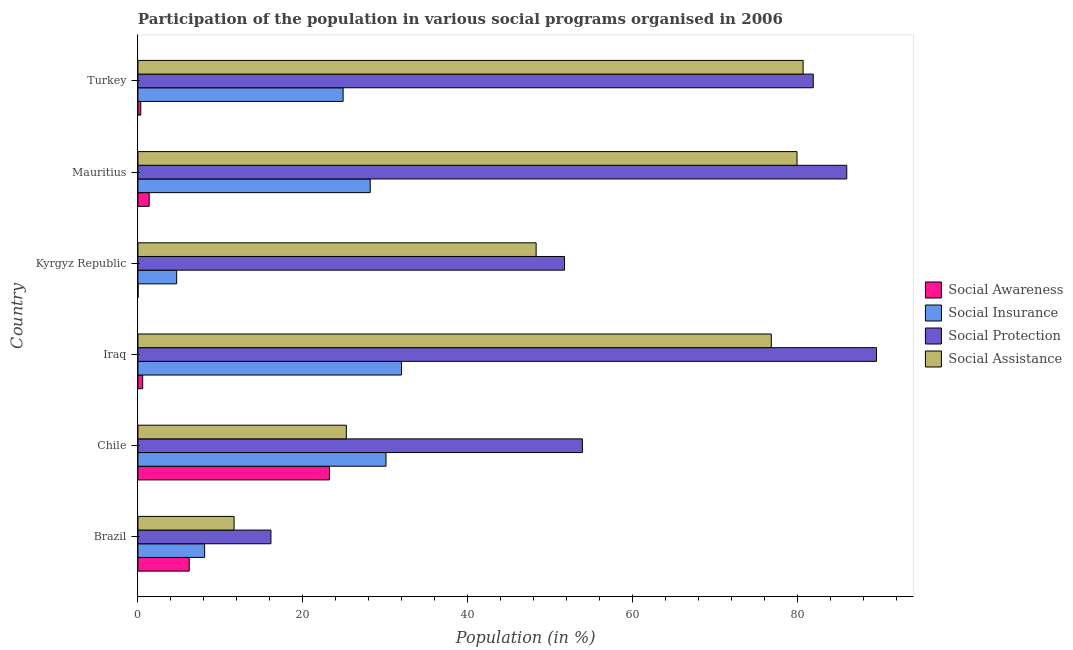How many different coloured bars are there?
Offer a very short reply. 4. Are the number of bars on each tick of the Y-axis equal?
Your response must be concise. Yes. How many bars are there on the 6th tick from the top?
Your response must be concise. 4. What is the label of the 4th group of bars from the top?
Give a very brief answer. Iraq. In how many cases, is the number of bars for a given country not equal to the number of legend labels?
Make the answer very short. 0. What is the participation of population in social awareness programs in Iraq?
Your response must be concise. 0.57. Across all countries, what is the maximum participation of population in social awareness programs?
Provide a succinct answer. 23.24. Across all countries, what is the minimum participation of population in social awareness programs?
Make the answer very short. 0.02. In which country was the participation of population in social protection programs maximum?
Your answer should be very brief. Iraq. What is the total participation of population in social insurance programs in the graph?
Offer a very short reply. 127.95. What is the difference between the participation of population in social insurance programs in Brazil and that in Turkey?
Ensure brevity in your answer.  -16.8. What is the difference between the participation of population in social assistance programs in Brazil and the participation of population in social protection programs in Turkey?
Provide a succinct answer. -70.28. What is the average participation of population in social assistance programs per country?
Keep it short and to the point. 53.8. What is the difference between the participation of population in social insurance programs and participation of population in social awareness programs in Brazil?
Offer a very short reply. 1.87. What is the ratio of the participation of population in social protection programs in Chile to that in Iraq?
Provide a succinct answer. 0.6. Is the difference between the participation of population in social insurance programs in Chile and Kyrgyz Republic greater than the difference between the participation of population in social assistance programs in Chile and Kyrgyz Republic?
Provide a short and direct response. Yes. What is the difference between the highest and the second highest participation of population in social awareness programs?
Give a very brief answer. 17.02. What is the difference between the highest and the lowest participation of population in social insurance programs?
Provide a succinct answer. 27.28. Is the sum of the participation of population in social insurance programs in Brazil and Turkey greater than the maximum participation of population in social assistance programs across all countries?
Your answer should be very brief. No. What does the 2nd bar from the top in Turkey represents?
Provide a short and direct response. Social Protection. What does the 3rd bar from the bottom in Iraq represents?
Provide a short and direct response. Social Protection. Is it the case that in every country, the sum of the participation of population in social awareness programs and participation of population in social insurance programs is greater than the participation of population in social protection programs?
Offer a terse response. No. How many countries are there in the graph?
Ensure brevity in your answer.  6. What is the difference between two consecutive major ticks on the X-axis?
Make the answer very short. 20. Are the values on the major ticks of X-axis written in scientific E-notation?
Ensure brevity in your answer.  No. Does the graph contain any zero values?
Give a very brief answer. No. Does the graph contain grids?
Offer a terse response. No. Where does the legend appear in the graph?
Your answer should be compact. Center right. What is the title of the graph?
Ensure brevity in your answer.  Participation of the population in various social programs organised in 2006. What is the label or title of the Y-axis?
Offer a terse response. Country. What is the Population (in %) in Social Awareness in Brazil?
Keep it short and to the point. 6.22. What is the Population (in %) of Social Insurance in Brazil?
Your answer should be compact. 8.09. What is the Population (in %) in Social Protection in Brazil?
Offer a terse response. 16.14. What is the Population (in %) of Social Assistance in Brazil?
Keep it short and to the point. 11.67. What is the Population (in %) in Social Awareness in Chile?
Offer a very short reply. 23.24. What is the Population (in %) in Social Insurance in Chile?
Your answer should be very brief. 30.1. What is the Population (in %) in Social Protection in Chile?
Provide a short and direct response. 53.93. What is the Population (in %) in Social Assistance in Chile?
Provide a succinct answer. 25.29. What is the Population (in %) of Social Awareness in Iraq?
Your answer should be very brief. 0.57. What is the Population (in %) in Social Insurance in Iraq?
Keep it short and to the point. 31.98. What is the Population (in %) in Social Protection in Iraq?
Give a very brief answer. 89.62. What is the Population (in %) of Social Assistance in Iraq?
Make the answer very short. 76.86. What is the Population (in %) of Social Awareness in Kyrgyz Republic?
Provide a succinct answer. 0.02. What is the Population (in %) of Social Insurance in Kyrgyz Republic?
Make the answer very short. 4.7. What is the Population (in %) of Social Protection in Kyrgyz Republic?
Offer a very short reply. 51.76. What is the Population (in %) of Social Assistance in Kyrgyz Republic?
Provide a short and direct response. 48.32. What is the Population (in %) of Social Awareness in Mauritius?
Offer a very short reply. 1.36. What is the Population (in %) in Social Insurance in Mauritius?
Your response must be concise. 28.19. What is the Population (in %) of Social Protection in Mauritius?
Provide a short and direct response. 86.01. What is the Population (in %) in Social Assistance in Mauritius?
Your response must be concise. 79.97. What is the Population (in %) of Social Awareness in Turkey?
Your response must be concise. 0.34. What is the Population (in %) of Social Insurance in Turkey?
Provide a short and direct response. 24.9. What is the Population (in %) in Social Protection in Turkey?
Make the answer very short. 81.95. What is the Population (in %) in Social Assistance in Turkey?
Your answer should be compact. 80.72. Across all countries, what is the maximum Population (in %) of Social Awareness?
Provide a short and direct response. 23.24. Across all countries, what is the maximum Population (in %) of Social Insurance?
Provide a short and direct response. 31.98. Across all countries, what is the maximum Population (in %) in Social Protection?
Your answer should be very brief. 89.62. Across all countries, what is the maximum Population (in %) of Social Assistance?
Your answer should be compact. 80.72. Across all countries, what is the minimum Population (in %) of Social Awareness?
Give a very brief answer. 0.02. Across all countries, what is the minimum Population (in %) of Social Insurance?
Provide a short and direct response. 4.7. Across all countries, what is the minimum Population (in %) of Social Protection?
Your response must be concise. 16.14. Across all countries, what is the minimum Population (in %) in Social Assistance?
Your answer should be very brief. 11.67. What is the total Population (in %) in Social Awareness in the graph?
Give a very brief answer. 31.75. What is the total Population (in %) of Social Insurance in the graph?
Offer a terse response. 127.95. What is the total Population (in %) in Social Protection in the graph?
Your answer should be very brief. 379.42. What is the total Population (in %) in Social Assistance in the graph?
Offer a very short reply. 322.82. What is the difference between the Population (in %) of Social Awareness in Brazil and that in Chile?
Offer a terse response. -17.02. What is the difference between the Population (in %) in Social Insurance in Brazil and that in Chile?
Provide a succinct answer. -22.01. What is the difference between the Population (in %) of Social Protection in Brazil and that in Chile?
Keep it short and to the point. -37.8. What is the difference between the Population (in %) in Social Assistance in Brazil and that in Chile?
Provide a succinct answer. -13.62. What is the difference between the Population (in %) of Social Awareness in Brazil and that in Iraq?
Give a very brief answer. 5.65. What is the difference between the Population (in %) in Social Insurance in Brazil and that in Iraq?
Ensure brevity in your answer.  -23.89. What is the difference between the Population (in %) in Social Protection in Brazil and that in Iraq?
Make the answer very short. -73.48. What is the difference between the Population (in %) of Social Assistance in Brazil and that in Iraq?
Give a very brief answer. -65.19. What is the difference between the Population (in %) in Social Awareness in Brazil and that in Kyrgyz Republic?
Keep it short and to the point. 6.21. What is the difference between the Population (in %) of Social Insurance in Brazil and that in Kyrgyz Republic?
Keep it short and to the point. 3.39. What is the difference between the Population (in %) in Social Protection in Brazil and that in Kyrgyz Republic?
Your response must be concise. -35.63. What is the difference between the Population (in %) of Social Assistance in Brazil and that in Kyrgyz Republic?
Your answer should be compact. -36.65. What is the difference between the Population (in %) of Social Awareness in Brazil and that in Mauritius?
Offer a terse response. 4.86. What is the difference between the Population (in %) in Social Insurance in Brazil and that in Mauritius?
Your answer should be very brief. -20.09. What is the difference between the Population (in %) of Social Protection in Brazil and that in Mauritius?
Your answer should be very brief. -69.88. What is the difference between the Population (in %) in Social Assistance in Brazil and that in Mauritius?
Make the answer very short. -68.31. What is the difference between the Population (in %) in Social Awareness in Brazil and that in Turkey?
Offer a terse response. 5.88. What is the difference between the Population (in %) of Social Insurance in Brazil and that in Turkey?
Offer a very short reply. -16.8. What is the difference between the Population (in %) in Social Protection in Brazil and that in Turkey?
Offer a terse response. -65.81. What is the difference between the Population (in %) in Social Assistance in Brazil and that in Turkey?
Ensure brevity in your answer.  -69.05. What is the difference between the Population (in %) in Social Awareness in Chile and that in Iraq?
Your answer should be very brief. 22.67. What is the difference between the Population (in %) of Social Insurance in Chile and that in Iraq?
Make the answer very short. -1.88. What is the difference between the Population (in %) in Social Protection in Chile and that in Iraq?
Offer a terse response. -35.69. What is the difference between the Population (in %) in Social Assistance in Chile and that in Iraq?
Your response must be concise. -51.57. What is the difference between the Population (in %) of Social Awareness in Chile and that in Kyrgyz Republic?
Offer a terse response. 23.22. What is the difference between the Population (in %) of Social Insurance in Chile and that in Kyrgyz Republic?
Your answer should be compact. 25.4. What is the difference between the Population (in %) of Social Protection in Chile and that in Kyrgyz Republic?
Offer a terse response. 2.17. What is the difference between the Population (in %) of Social Assistance in Chile and that in Kyrgyz Republic?
Provide a succinct answer. -23.03. What is the difference between the Population (in %) in Social Awareness in Chile and that in Mauritius?
Offer a very short reply. 21.87. What is the difference between the Population (in %) of Social Insurance in Chile and that in Mauritius?
Keep it short and to the point. 1.92. What is the difference between the Population (in %) of Social Protection in Chile and that in Mauritius?
Offer a terse response. -32.08. What is the difference between the Population (in %) in Social Assistance in Chile and that in Mauritius?
Offer a very short reply. -54.69. What is the difference between the Population (in %) of Social Awareness in Chile and that in Turkey?
Provide a succinct answer. 22.9. What is the difference between the Population (in %) of Social Insurance in Chile and that in Turkey?
Offer a very short reply. 5.21. What is the difference between the Population (in %) in Social Protection in Chile and that in Turkey?
Your response must be concise. -28.02. What is the difference between the Population (in %) in Social Assistance in Chile and that in Turkey?
Keep it short and to the point. -55.43. What is the difference between the Population (in %) of Social Awareness in Iraq and that in Kyrgyz Republic?
Make the answer very short. 0.56. What is the difference between the Population (in %) of Social Insurance in Iraq and that in Kyrgyz Republic?
Ensure brevity in your answer.  27.28. What is the difference between the Population (in %) in Social Protection in Iraq and that in Kyrgyz Republic?
Provide a short and direct response. 37.86. What is the difference between the Population (in %) of Social Assistance in Iraq and that in Kyrgyz Republic?
Your answer should be compact. 28.54. What is the difference between the Population (in %) in Social Awareness in Iraq and that in Mauritius?
Your answer should be compact. -0.79. What is the difference between the Population (in %) of Social Insurance in Iraq and that in Mauritius?
Give a very brief answer. 3.79. What is the difference between the Population (in %) of Social Protection in Iraq and that in Mauritius?
Offer a very short reply. 3.61. What is the difference between the Population (in %) in Social Assistance in Iraq and that in Mauritius?
Offer a very short reply. -3.12. What is the difference between the Population (in %) of Social Awareness in Iraq and that in Turkey?
Keep it short and to the point. 0.23. What is the difference between the Population (in %) of Social Insurance in Iraq and that in Turkey?
Provide a short and direct response. 7.08. What is the difference between the Population (in %) of Social Protection in Iraq and that in Turkey?
Give a very brief answer. 7.67. What is the difference between the Population (in %) in Social Assistance in Iraq and that in Turkey?
Provide a short and direct response. -3.86. What is the difference between the Population (in %) in Social Awareness in Kyrgyz Republic and that in Mauritius?
Provide a succinct answer. -1.35. What is the difference between the Population (in %) in Social Insurance in Kyrgyz Republic and that in Mauritius?
Provide a succinct answer. -23.49. What is the difference between the Population (in %) of Social Protection in Kyrgyz Republic and that in Mauritius?
Your response must be concise. -34.25. What is the difference between the Population (in %) in Social Assistance in Kyrgyz Republic and that in Mauritius?
Offer a terse response. -31.66. What is the difference between the Population (in %) of Social Awareness in Kyrgyz Republic and that in Turkey?
Keep it short and to the point. -0.33. What is the difference between the Population (in %) of Social Insurance in Kyrgyz Republic and that in Turkey?
Your response must be concise. -20.2. What is the difference between the Population (in %) in Social Protection in Kyrgyz Republic and that in Turkey?
Offer a very short reply. -30.19. What is the difference between the Population (in %) in Social Assistance in Kyrgyz Republic and that in Turkey?
Provide a succinct answer. -32.4. What is the difference between the Population (in %) in Social Awareness in Mauritius and that in Turkey?
Give a very brief answer. 1.02. What is the difference between the Population (in %) in Social Insurance in Mauritius and that in Turkey?
Offer a very short reply. 3.29. What is the difference between the Population (in %) in Social Protection in Mauritius and that in Turkey?
Your response must be concise. 4.07. What is the difference between the Population (in %) in Social Assistance in Mauritius and that in Turkey?
Your answer should be very brief. -0.74. What is the difference between the Population (in %) of Social Awareness in Brazil and the Population (in %) of Social Insurance in Chile?
Your answer should be very brief. -23.88. What is the difference between the Population (in %) in Social Awareness in Brazil and the Population (in %) in Social Protection in Chile?
Your answer should be very brief. -47.71. What is the difference between the Population (in %) in Social Awareness in Brazil and the Population (in %) in Social Assistance in Chile?
Make the answer very short. -19.07. What is the difference between the Population (in %) of Social Insurance in Brazil and the Population (in %) of Social Protection in Chile?
Your answer should be compact. -45.84. What is the difference between the Population (in %) in Social Insurance in Brazil and the Population (in %) in Social Assistance in Chile?
Ensure brevity in your answer.  -17.2. What is the difference between the Population (in %) in Social Protection in Brazil and the Population (in %) in Social Assistance in Chile?
Make the answer very short. -9.15. What is the difference between the Population (in %) of Social Awareness in Brazil and the Population (in %) of Social Insurance in Iraq?
Offer a terse response. -25.76. What is the difference between the Population (in %) in Social Awareness in Brazil and the Population (in %) in Social Protection in Iraq?
Give a very brief answer. -83.4. What is the difference between the Population (in %) in Social Awareness in Brazil and the Population (in %) in Social Assistance in Iraq?
Offer a terse response. -70.64. What is the difference between the Population (in %) of Social Insurance in Brazil and the Population (in %) of Social Protection in Iraq?
Provide a short and direct response. -81.53. What is the difference between the Population (in %) in Social Insurance in Brazil and the Population (in %) in Social Assistance in Iraq?
Offer a terse response. -68.76. What is the difference between the Population (in %) of Social Protection in Brazil and the Population (in %) of Social Assistance in Iraq?
Your response must be concise. -60.72. What is the difference between the Population (in %) of Social Awareness in Brazil and the Population (in %) of Social Insurance in Kyrgyz Republic?
Offer a very short reply. 1.52. What is the difference between the Population (in %) in Social Awareness in Brazil and the Population (in %) in Social Protection in Kyrgyz Republic?
Your answer should be compact. -45.54. What is the difference between the Population (in %) in Social Awareness in Brazil and the Population (in %) in Social Assistance in Kyrgyz Republic?
Provide a succinct answer. -42.1. What is the difference between the Population (in %) of Social Insurance in Brazil and the Population (in %) of Social Protection in Kyrgyz Republic?
Keep it short and to the point. -43.67. What is the difference between the Population (in %) in Social Insurance in Brazil and the Population (in %) in Social Assistance in Kyrgyz Republic?
Make the answer very short. -40.23. What is the difference between the Population (in %) in Social Protection in Brazil and the Population (in %) in Social Assistance in Kyrgyz Republic?
Your answer should be very brief. -32.18. What is the difference between the Population (in %) of Social Awareness in Brazil and the Population (in %) of Social Insurance in Mauritius?
Provide a succinct answer. -21.96. What is the difference between the Population (in %) in Social Awareness in Brazil and the Population (in %) in Social Protection in Mauritius?
Make the answer very short. -79.79. What is the difference between the Population (in %) of Social Awareness in Brazil and the Population (in %) of Social Assistance in Mauritius?
Offer a terse response. -73.75. What is the difference between the Population (in %) of Social Insurance in Brazil and the Population (in %) of Social Protection in Mauritius?
Your answer should be very brief. -77.92. What is the difference between the Population (in %) in Social Insurance in Brazil and the Population (in %) in Social Assistance in Mauritius?
Ensure brevity in your answer.  -71.88. What is the difference between the Population (in %) in Social Protection in Brazil and the Population (in %) in Social Assistance in Mauritius?
Ensure brevity in your answer.  -63.84. What is the difference between the Population (in %) of Social Awareness in Brazil and the Population (in %) of Social Insurance in Turkey?
Your response must be concise. -18.67. What is the difference between the Population (in %) of Social Awareness in Brazil and the Population (in %) of Social Protection in Turkey?
Provide a short and direct response. -75.73. What is the difference between the Population (in %) in Social Awareness in Brazil and the Population (in %) in Social Assistance in Turkey?
Offer a terse response. -74.5. What is the difference between the Population (in %) in Social Insurance in Brazil and the Population (in %) in Social Protection in Turkey?
Your answer should be very brief. -73.86. What is the difference between the Population (in %) in Social Insurance in Brazil and the Population (in %) in Social Assistance in Turkey?
Give a very brief answer. -72.63. What is the difference between the Population (in %) of Social Protection in Brazil and the Population (in %) of Social Assistance in Turkey?
Provide a short and direct response. -64.58. What is the difference between the Population (in %) in Social Awareness in Chile and the Population (in %) in Social Insurance in Iraq?
Give a very brief answer. -8.74. What is the difference between the Population (in %) of Social Awareness in Chile and the Population (in %) of Social Protection in Iraq?
Ensure brevity in your answer.  -66.38. What is the difference between the Population (in %) of Social Awareness in Chile and the Population (in %) of Social Assistance in Iraq?
Make the answer very short. -53.62. What is the difference between the Population (in %) of Social Insurance in Chile and the Population (in %) of Social Protection in Iraq?
Your answer should be compact. -59.52. What is the difference between the Population (in %) in Social Insurance in Chile and the Population (in %) in Social Assistance in Iraq?
Your answer should be very brief. -46.76. What is the difference between the Population (in %) of Social Protection in Chile and the Population (in %) of Social Assistance in Iraq?
Make the answer very short. -22.92. What is the difference between the Population (in %) of Social Awareness in Chile and the Population (in %) of Social Insurance in Kyrgyz Republic?
Your answer should be compact. 18.54. What is the difference between the Population (in %) of Social Awareness in Chile and the Population (in %) of Social Protection in Kyrgyz Republic?
Your response must be concise. -28.53. What is the difference between the Population (in %) of Social Awareness in Chile and the Population (in %) of Social Assistance in Kyrgyz Republic?
Give a very brief answer. -25.08. What is the difference between the Population (in %) in Social Insurance in Chile and the Population (in %) in Social Protection in Kyrgyz Republic?
Your response must be concise. -21.66. What is the difference between the Population (in %) in Social Insurance in Chile and the Population (in %) in Social Assistance in Kyrgyz Republic?
Make the answer very short. -18.22. What is the difference between the Population (in %) of Social Protection in Chile and the Population (in %) of Social Assistance in Kyrgyz Republic?
Provide a short and direct response. 5.62. What is the difference between the Population (in %) of Social Awareness in Chile and the Population (in %) of Social Insurance in Mauritius?
Provide a succinct answer. -4.95. What is the difference between the Population (in %) of Social Awareness in Chile and the Population (in %) of Social Protection in Mauritius?
Offer a terse response. -62.78. What is the difference between the Population (in %) in Social Awareness in Chile and the Population (in %) in Social Assistance in Mauritius?
Provide a short and direct response. -56.74. What is the difference between the Population (in %) in Social Insurance in Chile and the Population (in %) in Social Protection in Mauritius?
Keep it short and to the point. -55.91. What is the difference between the Population (in %) of Social Insurance in Chile and the Population (in %) of Social Assistance in Mauritius?
Offer a very short reply. -49.87. What is the difference between the Population (in %) of Social Protection in Chile and the Population (in %) of Social Assistance in Mauritius?
Provide a short and direct response. -26.04. What is the difference between the Population (in %) of Social Awareness in Chile and the Population (in %) of Social Insurance in Turkey?
Make the answer very short. -1.66. What is the difference between the Population (in %) in Social Awareness in Chile and the Population (in %) in Social Protection in Turkey?
Ensure brevity in your answer.  -58.71. What is the difference between the Population (in %) in Social Awareness in Chile and the Population (in %) in Social Assistance in Turkey?
Provide a succinct answer. -57.48. What is the difference between the Population (in %) of Social Insurance in Chile and the Population (in %) of Social Protection in Turkey?
Your answer should be compact. -51.85. What is the difference between the Population (in %) in Social Insurance in Chile and the Population (in %) in Social Assistance in Turkey?
Give a very brief answer. -50.62. What is the difference between the Population (in %) of Social Protection in Chile and the Population (in %) of Social Assistance in Turkey?
Your answer should be very brief. -26.79. What is the difference between the Population (in %) in Social Awareness in Iraq and the Population (in %) in Social Insurance in Kyrgyz Republic?
Provide a short and direct response. -4.13. What is the difference between the Population (in %) in Social Awareness in Iraq and the Population (in %) in Social Protection in Kyrgyz Republic?
Give a very brief answer. -51.19. What is the difference between the Population (in %) in Social Awareness in Iraq and the Population (in %) in Social Assistance in Kyrgyz Republic?
Give a very brief answer. -47.75. What is the difference between the Population (in %) of Social Insurance in Iraq and the Population (in %) of Social Protection in Kyrgyz Republic?
Give a very brief answer. -19.78. What is the difference between the Population (in %) of Social Insurance in Iraq and the Population (in %) of Social Assistance in Kyrgyz Republic?
Provide a succinct answer. -16.34. What is the difference between the Population (in %) of Social Protection in Iraq and the Population (in %) of Social Assistance in Kyrgyz Republic?
Offer a terse response. 41.3. What is the difference between the Population (in %) in Social Awareness in Iraq and the Population (in %) in Social Insurance in Mauritius?
Make the answer very short. -27.61. What is the difference between the Population (in %) in Social Awareness in Iraq and the Population (in %) in Social Protection in Mauritius?
Offer a very short reply. -85.44. What is the difference between the Population (in %) in Social Awareness in Iraq and the Population (in %) in Social Assistance in Mauritius?
Provide a succinct answer. -79.4. What is the difference between the Population (in %) in Social Insurance in Iraq and the Population (in %) in Social Protection in Mauritius?
Offer a terse response. -54.04. What is the difference between the Population (in %) in Social Insurance in Iraq and the Population (in %) in Social Assistance in Mauritius?
Make the answer very short. -48. What is the difference between the Population (in %) in Social Protection in Iraq and the Population (in %) in Social Assistance in Mauritius?
Ensure brevity in your answer.  9.65. What is the difference between the Population (in %) of Social Awareness in Iraq and the Population (in %) of Social Insurance in Turkey?
Offer a very short reply. -24.32. What is the difference between the Population (in %) of Social Awareness in Iraq and the Population (in %) of Social Protection in Turkey?
Keep it short and to the point. -81.38. What is the difference between the Population (in %) in Social Awareness in Iraq and the Population (in %) in Social Assistance in Turkey?
Your answer should be very brief. -80.15. What is the difference between the Population (in %) of Social Insurance in Iraq and the Population (in %) of Social Protection in Turkey?
Give a very brief answer. -49.97. What is the difference between the Population (in %) in Social Insurance in Iraq and the Population (in %) in Social Assistance in Turkey?
Provide a succinct answer. -48.74. What is the difference between the Population (in %) in Social Protection in Iraq and the Population (in %) in Social Assistance in Turkey?
Provide a short and direct response. 8.9. What is the difference between the Population (in %) in Social Awareness in Kyrgyz Republic and the Population (in %) in Social Insurance in Mauritius?
Provide a succinct answer. -28.17. What is the difference between the Population (in %) of Social Awareness in Kyrgyz Republic and the Population (in %) of Social Protection in Mauritius?
Provide a succinct answer. -86. What is the difference between the Population (in %) in Social Awareness in Kyrgyz Republic and the Population (in %) in Social Assistance in Mauritius?
Offer a terse response. -79.96. What is the difference between the Population (in %) of Social Insurance in Kyrgyz Republic and the Population (in %) of Social Protection in Mauritius?
Provide a succinct answer. -81.32. What is the difference between the Population (in %) of Social Insurance in Kyrgyz Republic and the Population (in %) of Social Assistance in Mauritius?
Provide a short and direct response. -75.28. What is the difference between the Population (in %) in Social Protection in Kyrgyz Republic and the Population (in %) in Social Assistance in Mauritius?
Your answer should be very brief. -28.21. What is the difference between the Population (in %) of Social Awareness in Kyrgyz Republic and the Population (in %) of Social Insurance in Turkey?
Offer a terse response. -24.88. What is the difference between the Population (in %) of Social Awareness in Kyrgyz Republic and the Population (in %) of Social Protection in Turkey?
Your answer should be very brief. -81.93. What is the difference between the Population (in %) in Social Awareness in Kyrgyz Republic and the Population (in %) in Social Assistance in Turkey?
Offer a very short reply. -80.7. What is the difference between the Population (in %) in Social Insurance in Kyrgyz Republic and the Population (in %) in Social Protection in Turkey?
Offer a very short reply. -77.25. What is the difference between the Population (in %) in Social Insurance in Kyrgyz Republic and the Population (in %) in Social Assistance in Turkey?
Provide a short and direct response. -76.02. What is the difference between the Population (in %) of Social Protection in Kyrgyz Republic and the Population (in %) of Social Assistance in Turkey?
Give a very brief answer. -28.96. What is the difference between the Population (in %) in Social Awareness in Mauritius and the Population (in %) in Social Insurance in Turkey?
Make the answer very short. -23.53. What is the difference between the Population (in %) in Social Awareness in Mauritius and the Population (in %) in Social Protection in Turkey?
Ensure brevity in your answer.  -80.59. What is the difference between the Population (in %) of Social Awareness in Mauritius and the Population (in %) of Social Assistance in Turkey?
Ensure brevity in your answer.  -79.36. What is the difference between the Population (in %) in Social Insurance in Mauritius and the Population (in %) in Social Protection in Turkey?
Your answer should be compact. -53.76. What is the difference between the Population (in %) in Social Insurance in Mauritius and the Population (in %) in Social Assistance in Turkey?
Make the answer very short. -52.53. What is the difference between the Population (in %) of Social Protection in Mauritius and the Population (in %) of Social Assistance in Turkey?
Provide a succinct answer. 5.3. What is the average Population (in %) in Social Awareness per country?
Ensure brevity in your answer.  5.29. What is the average Population (in %) of Social Insurance per country?
Give a very brief answer. 21.33. What is the average Population (in %) in Social Protection per country?
Keep it short and to the point. 63.24. What is the average Population (in %) of Social Assistance per country?
Keep it short and to the point. 53.8. What is the difference between the Population (in %) of Social Awareness and Population (in %) of Social Insurance in Brazil?
Keep it short and to the point. -1.87. What is the difference between the Population (in %) in Social Awareness and Population (in %) in Social Protection in Brazil?
Give a very brief answer. -9.92. What is the difference between the Population (in %) in Social Awareness and Population (in %) in Social Assistance in Brazil?
Ensure brevity in your answer.  -5.44. What is the difference between the Population (in %) of Social Insurance and Population (in %) of Social Protection in Brazil?
Offer a terse response. -8.04. What is the difference between the Population (in %) of Social Insurance and Population (in %) of Social Assistance in Brazil?
Ensure brevity in your answer.  -3.57. What is the difference between the Population (in %) in Social Protection and Population (in %) in Social Assistance in Brazil?
Offer a terse response. 4.47. What is the difference between the Population (in %) of Social Awareness and Population (in %) of Social Insurance in Chile?
Your answer should be compact. -6.86. What is the difference between the Population (in %) in Social Awareness and Population (in %) in Social Protection in Chile?
Make the answer very short. -30.7. What is the difference between the Population (in %) in Social Awareness and Population (in %) in Social Assistance in Chile?
Your response must be concise. -2.05. What is the difference between the Population (in %) of Social Insurance and Population (in %) of Social Protection in Chile?
Offer a terse response. -23.83. What is the difference between the Population (in %) of Social Insurance and Population (in %) of Social Assistance in Chile?
Give a very brief answer. 4.81. What is the difference between the Population (in %) in Social Protection and Population (in %) in Social Assistance in Chile?
Ensure brevity in your answer.  28.64. What is the difference between the Population (in %) in Social Awareness and Population (in %) in Social Insurance in Iraq?
Ensure brevity in your answer.  -31.41. What is the difference between the Population (in %) in Social Awareness and Population (in %) in Social Protection in Iraq?
Your answer should be very brief. -89.05. What is the difference between the Population (in %) of Social Awareness and Population (in %) of Social Assistance in Iraq?
Provide a succinct answer. -76.29. What is the difference between the Population (in %) of Social Insurance and Population (in %) of Social Protection in Iraq?
Your answer should be very brief. -57.64. What is the difference between the Population (in %) in Social Insurance and Population (in %) in Social Assistance in Iraq?
Ensure brevity in your answer.  -44.88. What is the difference between the Population (in %) in Social Protection and Population (in %) in Social Assistance in Iraq?
Make the answer very short. 12.76. What is the difference between the Population (in %) of Social Awareness and Population (in %) of Social Insurance in Kyrgyz Republic?
Provide a short and direct response. -4.68. What is the difference between the Population (in %) in Social Awareness and Population (in %) in Social Protection in Kyrgyz Republic?
Provide a short and direct response. -51.75. What is the difference between the Population (in %) of Social Awareness and Population (in %) of Social Assistance in Kyrgyz Republic?
Keep it short and to the point. -48.3. What is the difference between the Population (in %) of Social Insurance and Population (in %) of Social Protection in Kyrgyz Republic?
Make the answer very short. -47.06. What is the difference between the Population (in %) in Social Insurance and Population (in %) in Social Assistance in Kyrgyz Republic?
Your response must be concise. -43.62. What is the difference between the Population (in %) of Social Protection and Population (in %) of Social Assistance in Kyrgyz Republic?
Your answer should be very brief. 3.45. What is the difference between the Population (in %) of Social Awareness and Population (in %) of Social Insurance in Mauritius?
Your answer should be compact. -26.82. What is the difference between the Population (in %) in Social Awareness and Population (in %) in Social Protection in Mauritius?
Give a very brief answer. -84.65. What is the difference between the Population (in %) of Social Awareness and Population (in %) of Social Assistance in Mauritius?
Your answer should be compact. -78.61. What is the difference between the Population (in %) in Social Insurance and Population (in %) in Social Protection in Mauritius?
Provide a succinct answer. -57.83. What is the difference between the Population (in %) in Social Insurance and Population (in %) in Social Assistance in Mauritius?
Your response must be concise. -51.79. What is the difference between the Population (in %) in Social Protection and Population (in %) in Social Assistance in Mauritius?
Your answer should be compact. 6.04. What is the difference between the Population (in %) of Social Awareness and Population (in %) of Social Insurance in Turkey?
Give a very brief answer. -24.55. What is the difference between the Population (in %) in Social Awareness and Population (in %) in Social Protection in Turkey?
Your response must be concise. -81.61. What is the difference between the Population (in %) of Social Awareness and Population (in %) of Social Assistance in Turkey?
Provide a succinct answer. -80.38. What is the difference between the Population (in %) of Social Insurance and Population (in %) of Social Protection in Turkey?
Your answer should be compact. -57.05. What is the difference between the Population (in %) of Social Insurance and Population (in %) of Social Assistance in Turkey?
Provide a short and direct response. -55.82. What is the difference between the Population (in %) in Social Protection and Population (in %) in Social Assistance in Turkey?
Ensure brevity in your answer.  1.23. What is the ratio of the Population (in %) of Social Awareness in Brazil to that in Chile?
Ensure brevity in your answer.  0.27. What is the ratio of the Population (in %) of Social Insurance in Brazil to that in Chile?
Give a very brief answer. 0.27. What is the ratio of the Population (in %) in Social Protection in Brazil to that in Chile?
Make the answer very short. 0.3. What is the ratio of the Population (in %) in Social Assistance in Brazil to that in Chile?
Keep it short and to the point. 0.46. What is the ratio of the Population (in %) in Social Awareness in Brazil to that in Iraq?
Ensure brevity in your answer.  10.88. What is the ratio of the Population (in %) in Social Insurance in Brazil to that in Iraq?
Your answer should be very brief. 0.25. What is the ratio of the Population (in %) in Social Protection in Brazil to that in Iraq?
Your answer should be very brief. 0.18. What is the ratio of the Population (in %) in Social Assistance in Brazil to that in Iraq?
Provide a succinct answer. 0.15. What is the ratio of the Population (in %) of Social Awareness in Brazil to that in Kyrgyz Republic?
Your response must be concise. 410.01. What is the ratio of the Population (in %) of Social Insurance in Brazil to that in Kyrgyz Republic?
Make the answer very short. 1.72. What is the ratio of the Population (in %) of Social Protection in Brazil to that in Kyrgyz Republic?
Offer a very short reply. 0.31. What is the ratio of the Population (in %) in Social Assistance in Brazil to that in Kyrgyz Republic?
Provide a short and direct response. 0.24. What is the ratio of the Population (in %) in Social Awareness in Brazil to that in Mauritius?
Offer a very short reply. 4.57. What is the ratio of the Population (in %) of Social Insurance in Brazil to that in Mauritius?
Your answer should be compact. 0.29. What is the ratio of the Population (in %) in Social Protection in Brazil to that in Mauritius?
Provide a short and direct response. 0.19. What is the ratio of the Population (in %) in Social Assistance in Brazil to that in Mauritius?
Your answer should be compact. 0.15. What is the ratio of the Population (in %) in Social Awareness in Brazil to that in Turkey?
Provide a short and direct response. 18.24. What is the ratio of the Population (in %) in Social Insurance in Brazil to that in Turkey?
Provide a short and direct response. 0.33. What is the ratio of the Population (in %) in Social Protection in Brazil to that in Turkey?
Your answer should be compact. 0.2. What is the ratio of the Population (in %) in Social Assistance in Brazil to that in Turkey?
Give a very brief answer. 0.14. What is the ratio of the Population (in %) of Social Awareness in Chile to that in Iraq?
Give a very brief answer. 40.64. What is the ratio of the Population (in %) of Social Insurance in Chile to that in Iraq?
Your answer should be very brief. 0.94. What is the ratio of the Population (in %) in Social Protection in Chile to that in Iraq?
Ensure brevity in your answer.  0.6. What is the ratio of the Population (in %) of Social Assistance in Chile to that in Iraq?
Offer a terse response. 0.33. What is the ratio of the Population (in %) in Social Awareness in Chile to that in Kyrgyz Republic?
Give a very brief answer. 1531.39. What is the ratio of the Population (in %) of Social Insurance in Chile to that in Kyrgyz Republic?
Offer a terse response. 6.41. What is the ratio of the Population (in %) in Social Protection in Chile to that in Kyrgyz Republic?
Provide a succinct answer. 1.04. What is the ratio of the Population (in %) of Social Assistance in Chile to that in Kyrgyz Republic?
Ensure brevity in your answer.  0.52. What is the ratio of the Population (in %) of Social Awareness in Chile to that in Mauritius?
Give a very brief answer. 17.06. What is the ratio of the Population (in %) in Social Insurance in Chile to that in Mauritius?
Give a very brief answer. 1.07. What is the ratio of the Population (in %) of Social Protection in Chile to that in Mauritius?
Your answer should be very brief. 0.63. What is the ratio of the Population (in %) of Social Assistance in Chile to that in Mauritius?
Provide a succinct answer. 0.32. What is the ratio of the Population (in %) in Social Awareness in Chile to that in Turkey?
Provide a short and direct response. 68.11. What is the ratio of the Population (in %) in Social Insurance in Chile to that in Turkey?
Your answer should be compact. 1.21. What is the ratio of the Population (in %) of Social Protection in Chile to that in Turkey?
Keep it short and to the point. 0.66. What is the ratio of the Population (in %) in Social Assistance in Chile to that in Turkey?
Your response must be concise. 0.31. What is the ratio of the Population (in %) of Social Awareness in Iraq to that in Kyrgyz Republic?
Provide a short and direct response. 37.69. What is the ratio of the Population (in %) in Social Insurance in Iraq to that in Kyrgyz Republic?
Provide a succinct answer. 6.81. What is the ratio of the Population (in %) of Social Protection in Iraq to that in Kyrgyz Republic?
Keep it short and to the point. 1.73. What is the ratio of the Population (in %) of Social Assistance in Iraq to that in Kyrgyz Republic?
Make the answer very short. 1.59. What is the ratio of the Population (in %) of Social Awareness in Iraq to that in Mauritius?
Your response must be concise. 0.42. What is the ratio of the Population (in %) of Social Insurance in Iraq to that in Mauritius?
Your answer should be very brief. 1.13. What is the ratio of the Population (in %) of Social Protection in Iraq to that in Mauritius?
Keep it short and to the point. 1.04. What is the ratio of the Population (in %) of Social Assistance in Iraq to that in Mauritius?
Give a very brief answer. 0.96. What is the ratio of the Population (in %) of Social Awareness in Iraq to that in Turkey?
Provide a succinct answer. 1.68. What is the ratio of the Population (in %) of Social Insurance in Iraq to that in Turkey?
Your answer should be very brief. 1.28. What is the ratio of the Population (in %) in Social Protection in Iraq to that in Turkey?
Provide a short and direct response. 1.09. What is the ratio of the Population (in %) of Social Assistance in Iraq to that in Turkey?
Provide a short and direct response. 0.95. What is the ratio of the Population (in %) in Social Awareness in Kyrgyz Republic to that in Mauritius?
Your answer should be very brief. 0.01. What is the ratio of the Population (in %) of Social Insurance in Kyrgyz Republic to that in Mauritius?
Your response must be concise. 0.17. What is the ratio of the Population (in %) in Social Protection in Kyrgyz Republic to that in Mauritius?
Your response must be concise. 0.6. What is the ratio of the Population (in %) in Social Assistance in Kyrgyz Republic to that in Mauritius?
Provide a short and direct response. 0.6. What is the ratio of the Population (in %) of Social Awareness in Kyrgyz Republic to that in Turkey?
Provide a short and direct response. 0.04. What is the ratio of the Population (in %) in Social Insurance in Kyrgyz Republic to that in Turkey?
Your answer should be compact. 0.19. What is the ratio of the Population (in %) of Social Protection in Kyrgyz Republic to that in Turkey?
Provide a short and direct response. 0.63. What is the ratio of the Population (in %) in Social Assistance in Kyrgyz Republic to that in Turkey?
Give a very brief answer. 0.6. What is the ratio of the Population (in %) of Social Awareness in Mauritius to that in Turkey?
Your response must be concise. 3.99. What is the ratio of the Population (in %) of Social Insurance in Mauritius to that in Turkey?
Ensure brevity in your answer.  1.13. What is the ratio of the Population (in %) in Social Protection in Mauritius to that in Turkey?
Your answer should be compact. 1.05. What is the difference between the highest and the second highest Population (in %) of Social Awareness?
Your answer should be very brief. 17.02. What is the difference between the highest and the second highest Population (in %) in Social Insurance?
Your answer should be compact. 1.88. What is the difference between the highest and the second highest Population (in %) of Social Protection?
Keep it short and to the point. 3.61. What is the difference between the highest and the second highest Population (in %) in Social Assistance?
Ensure brevity in your answer.  0.74. What is the difference between the highest and the lowest Population (in %) in Social Awareness?
Ensure brevity in your answer.  23.22. What is the difference between the highest and the lowest Population (in %) in Social Insurance?
Your response must be concise. 27.28. What is the difference between the highest and the lowest Population (in %) in Social Protection?
Keep it short and to the point. 73.48. What is the difference between the highest and the lowest Population (in %) of Social Assistance?
Make the answer very short. 69.05. 